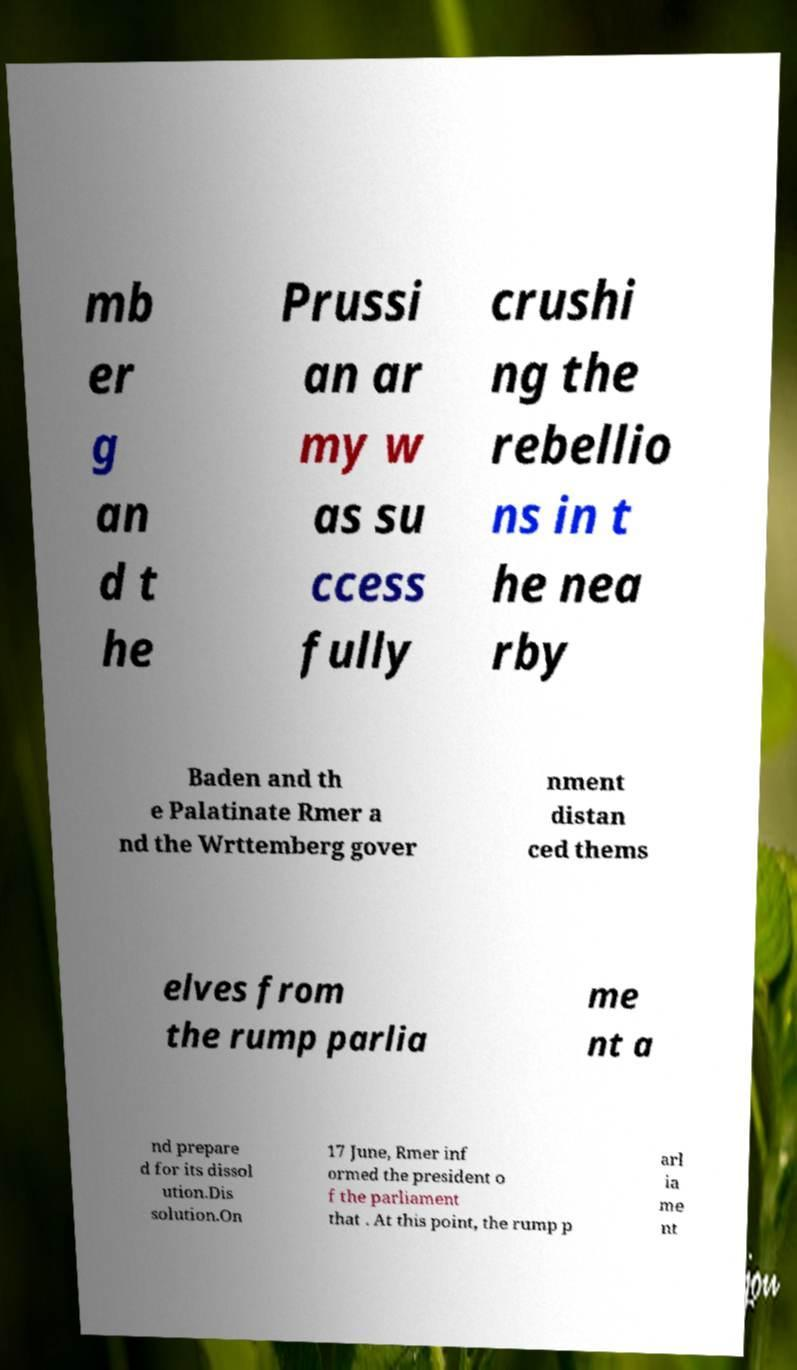What messages or text are displayed in this image? I need them in a readable, typed format. mb er g an d t he Prussi an ar my w as su ccess fully crushi ng the rebellio ns in t he nea rby Baden and th e Palatinate Rmer a nd the Wrttemberg gover nment distan ced thems elves from the rump parlia me nt a nd prepare d for its dissol ution.Dis solution.On 17 June, Rmer inf ormed the president o f the parliament that . At this point, the rump p arl ia me nt 